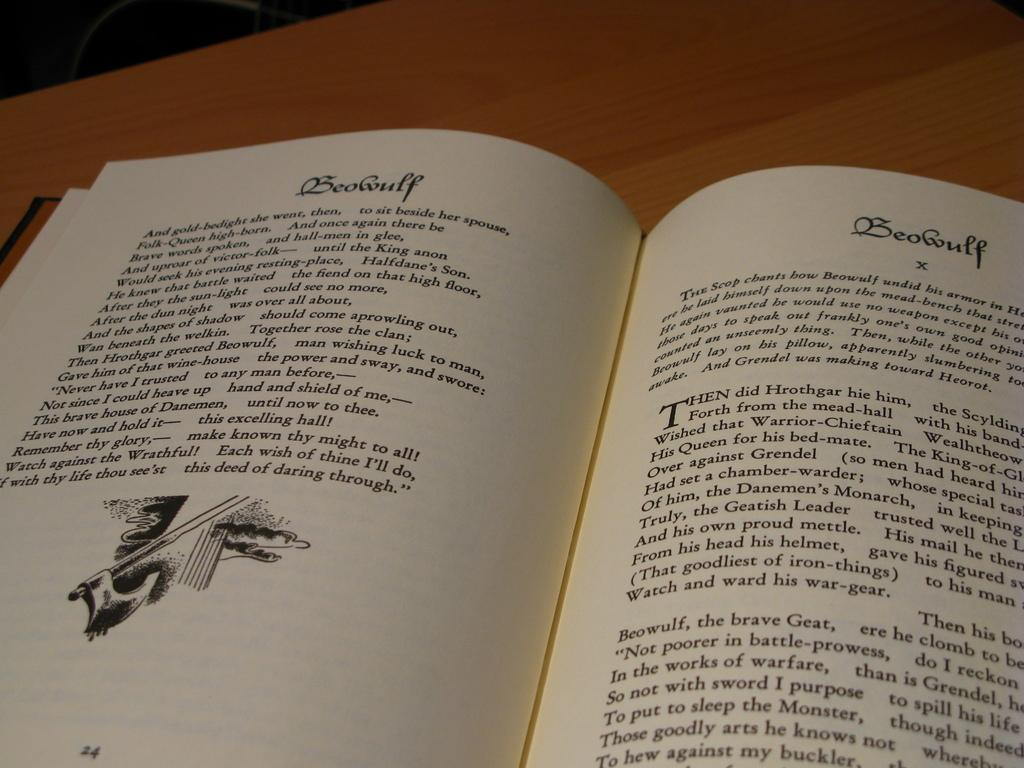<image>
Provide a brief description of the given image. A copy of Beowulf is open to page number 24. 